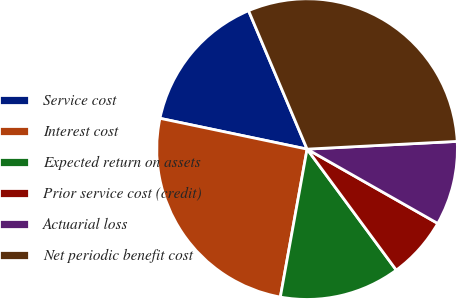Convert chart to OTSL. <chart><loc_0><loc_0><loc_500><loc_500><pie_chart><fcel>Service cost<fcel>Interest cost<fcel>Expected return on assets<fcel>Prior service cost (credit)<fcel>Actuarial loss<fcel>Net periodic benefit cost<nl><fcel>15.35%<fcel>25.44%<fcel>12.96%<fcel>6.66%<fcel>9.05%<fcel>30.55%<nl></chart> 